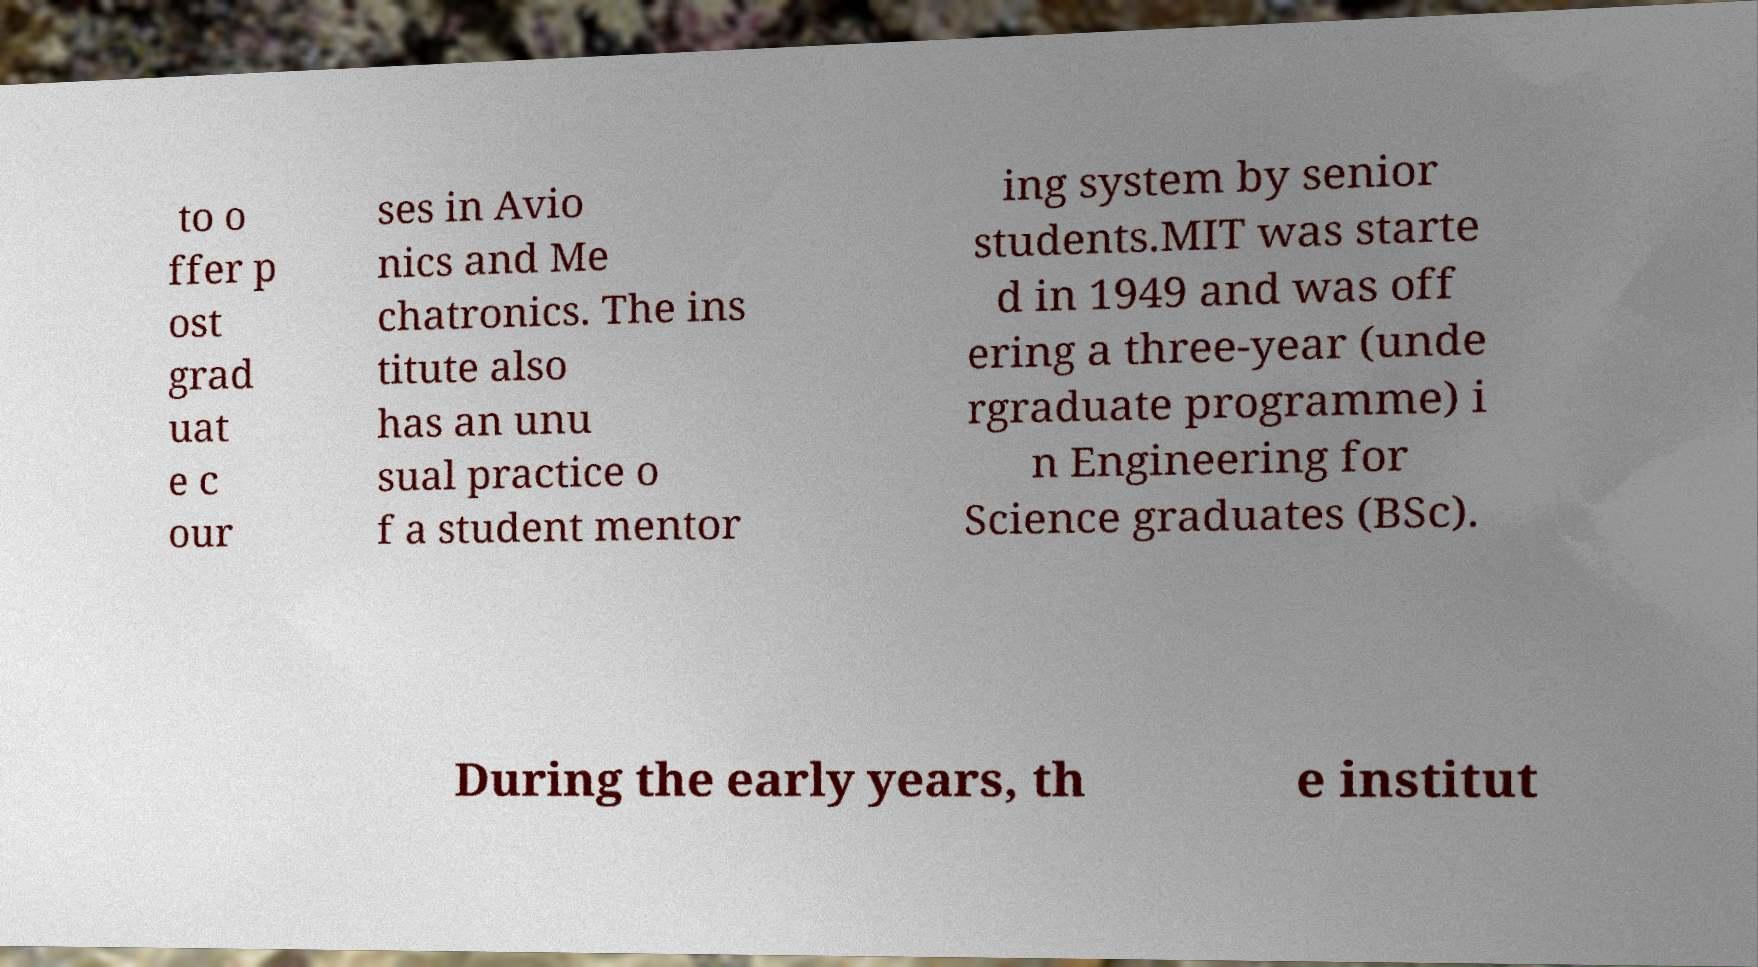Could you extract and type out the text from this image? to o ffer p ost grad uat e c our ses in Avio nics and Me chatronics. The ins titute also has an unu sual practice o f a student mentor ing system by senior students.MIT was starte d in 1949 and was off ering a three-year (unde rgraduate programme) i n Engineering for Science graduates (BSc). During the early years, th e institut 